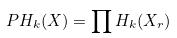Convert formula to latex. <formula><loc_0><loc_0><loc_500><loc_500>P H _ { k } ( X ) = \prod H _ { k } ( X _ { r } )</formula> 